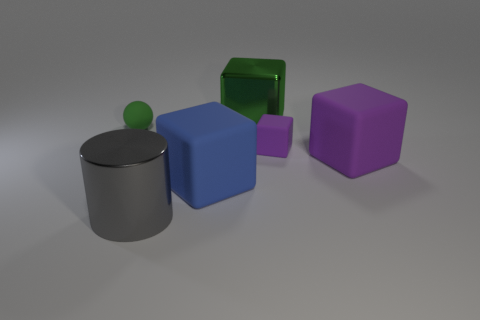Is the color of the small ball the same as the shiny block?
Give a very brief answer. Yes. What number of objects are either things behind the shiny cylinder or objects right of the gray cylinder?
Offer a very short reply. 5. How big is the cube on the left side of the big metal object right of the gray metal cylinder?
Offer a very short reply. Large. There is a object behind the small green matte thing; is it the same color as the tiny sphere?
Your answer should be compact. Yes. Is there a blue matte thing that has the same shape as the big green metallic object?
Ensure brevity in your answer.  Yes. What is the color of the other matte cube that is the same size as the blue rubber block?
Provide a short and direct response. Purple. What size is the shiny thing behind the large gray object?
Your answer should be compact. Large. Are there any matte blocks that are in front of the cube behind the tiny matte cube?
Your answer should be very brief. Yes. Does the purple block behind the big purple thing have the same material as the blue object?
Provide a short and direct response. Yes. What number of objects are both on the left side of the large purple rubber object and behind the gray metallic cylinder?
Provide a short and direct response. 4. 